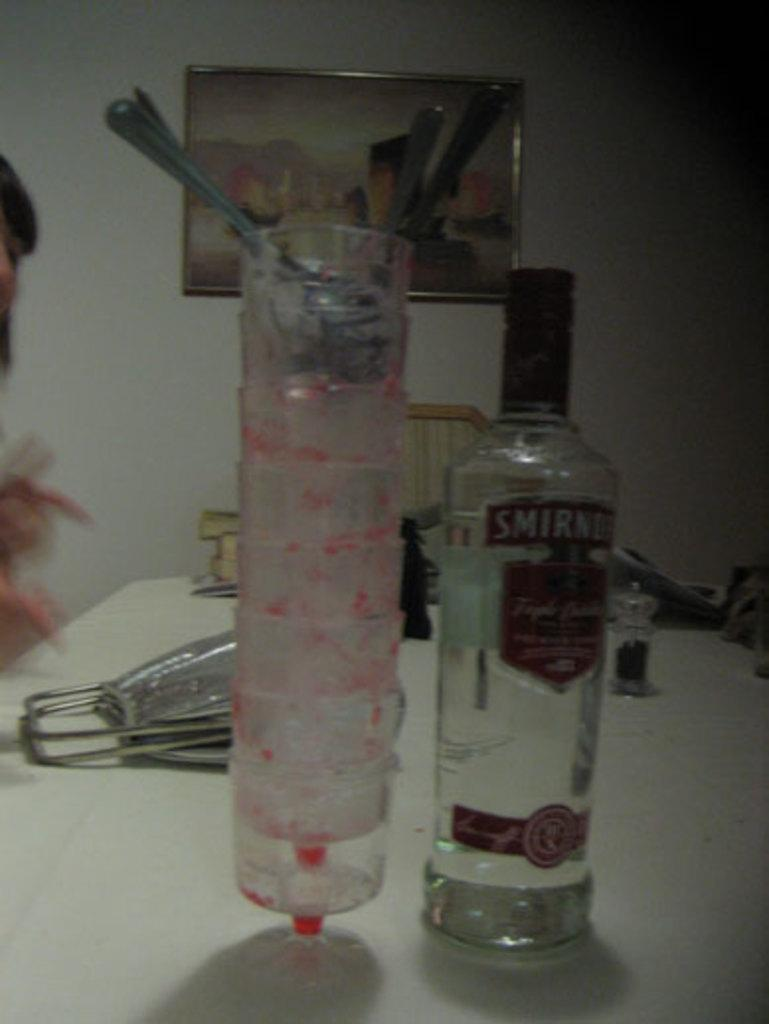What piece of furniture is present in the image? There is a table in the image. What items can be seen on the table? The table has glasses, a bottle, and a photo frame on it. Can you describe the contents of the glasses? There are spoons in the glasses. Where is the photo frame located on the table? The photo frame is on the backside of the table. What shape is the beef on the table in the image? There is no beef present in the image. How does the heart rate of the person in the photo frame change in the image? There is no information about a person or their heart rate in the image. 